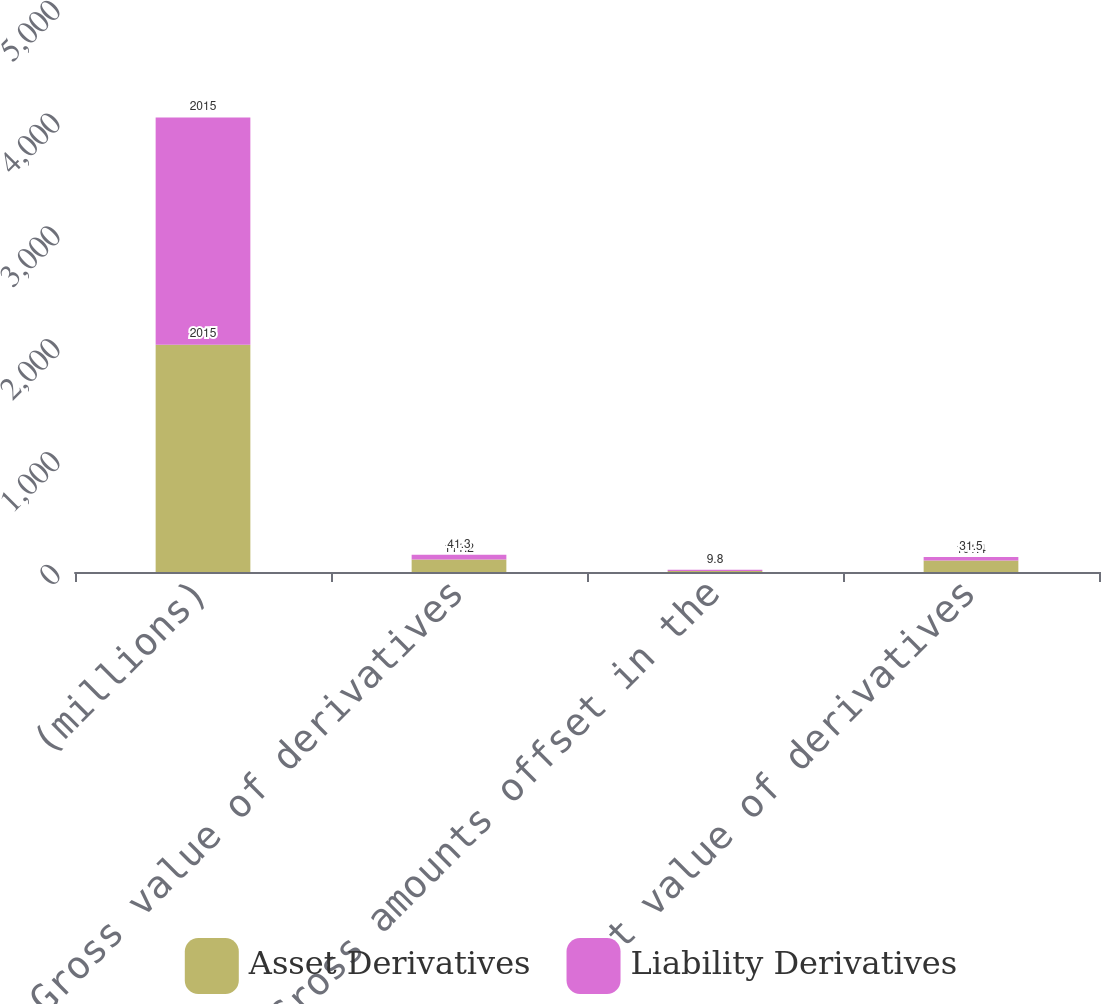Convert chart to OTSL. <chart><loc_0><loc_0><loc_500><loc_500><stacked_bar_chart><ecel><fcel>(millions)<fcel>Gross value of derivatives<fcel>Gross amounts offset in the<fcel>Net value of derivatives<nl><fcel>Asset Derivatives<fcel>2015<fcel>111.2<fcel>9.8<fcel>101.4<nl><fcel>Liability Derivatives<fcel>2015<fcel>41.3<fcel>9.8<fcel>31.5<nl></chart> 